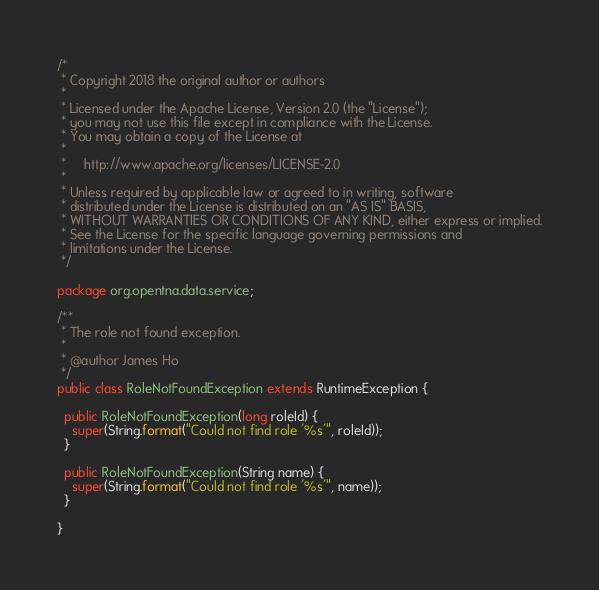Convert code to text. <code><loc_0><loc_0><loc_500><loc_500><_Java_>/*
 * Copyright 2018 the original author or authors
 *
 * Licensed under the Apache License, Version 2.0 (the "License");
 * you may not use this file except in compliance with the License.
 * You may obtain a copy of the License at
 *
 *     http://www.apache.org/licenses/LICENSE-2.0
 *
 * Unless required by applicable law or agreed to in writing, software
 * distributed under the License is distributed on an "AS IS" BASIS,
 * WITHOUT WARRANTIES OR CONDITIONS OF ANY KIND, either express or implied.
 * See the License for the specific language governing permissions and
 * limitations under the License.
 */

package org.opentna.data.service;

/**
 * The role not found exception.
 *
 * @author James Ho
 */
public class RoleNotFoundException extends RuntimeException {

  public RoleNotFoundException(long roleId) {
    super(String.format("Could not find role '%s'", roleId));
  }

  public RoleNotFoundException(String name) {
    super(String.format("Could not find role '%s'", name));
  }

}
</code> 